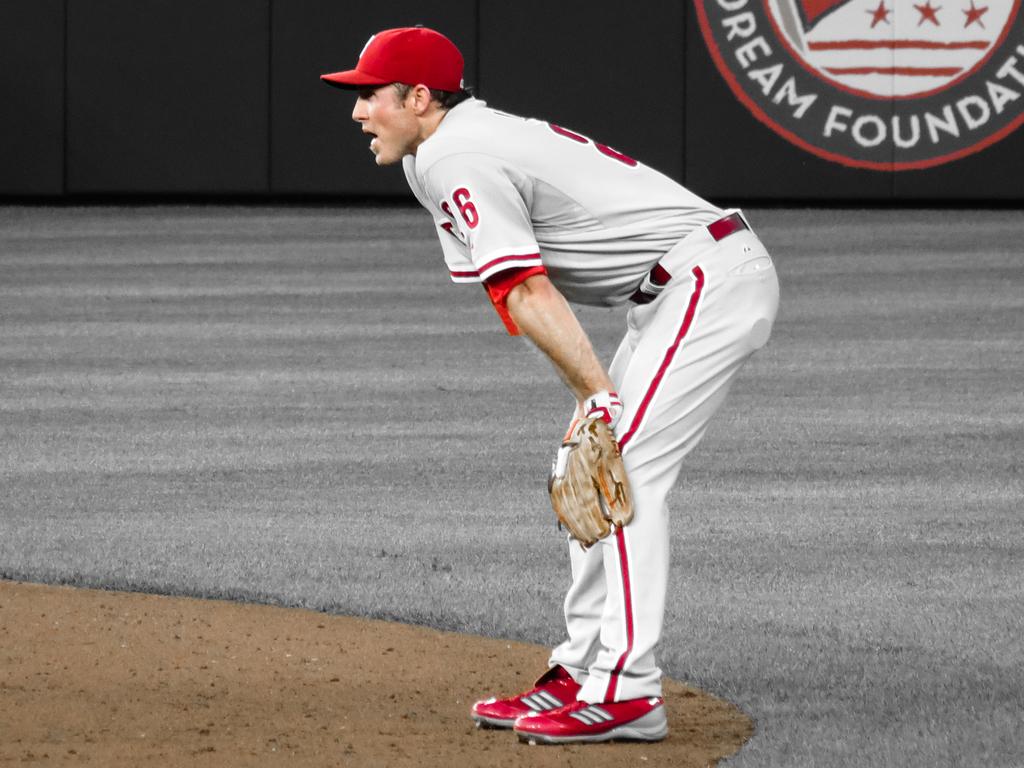What's this player's number?
Make the answer very short. 26. What foundation sponsors the game?
Offer a terse response. Dream foundation. 